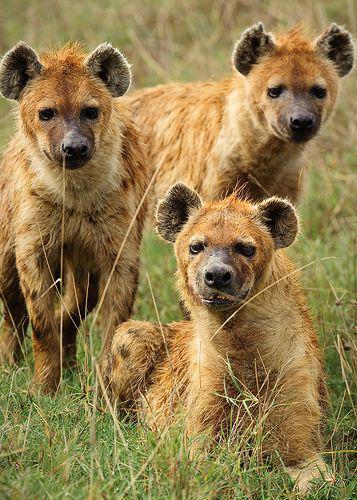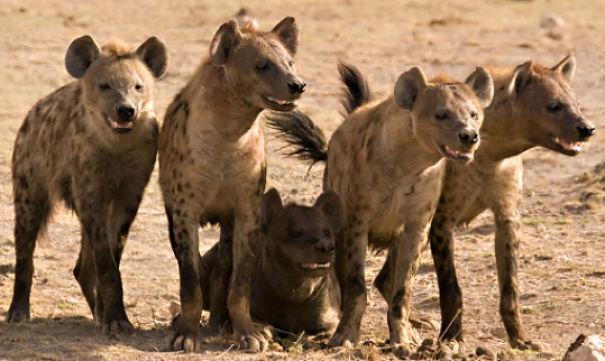The first image is the image on the left, the second image is the image on the right. Assess this claim about the two images: "There's no more than one hyena in the right image.". Correct or not? Answer yes or no. No. The first image is the image on the left, the second image is the image on the right. Considering the images on both sides, is "An image shows a closely grouped trio of hyenas looking at the camera, all with closed mouths." valid? Answer yes or no. Yes. 